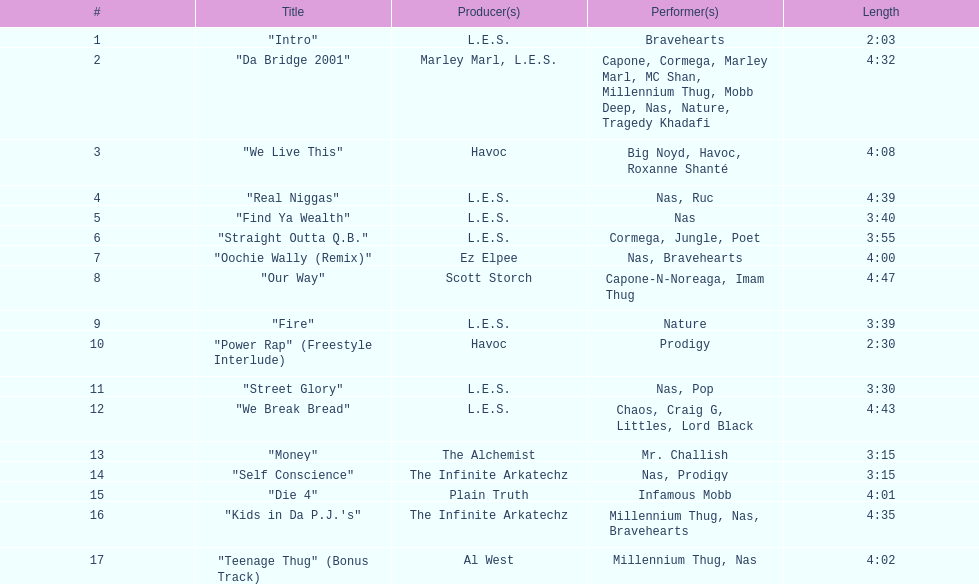What is the name of the last song on the album? "Teenage Thug" (Bonus Track). 